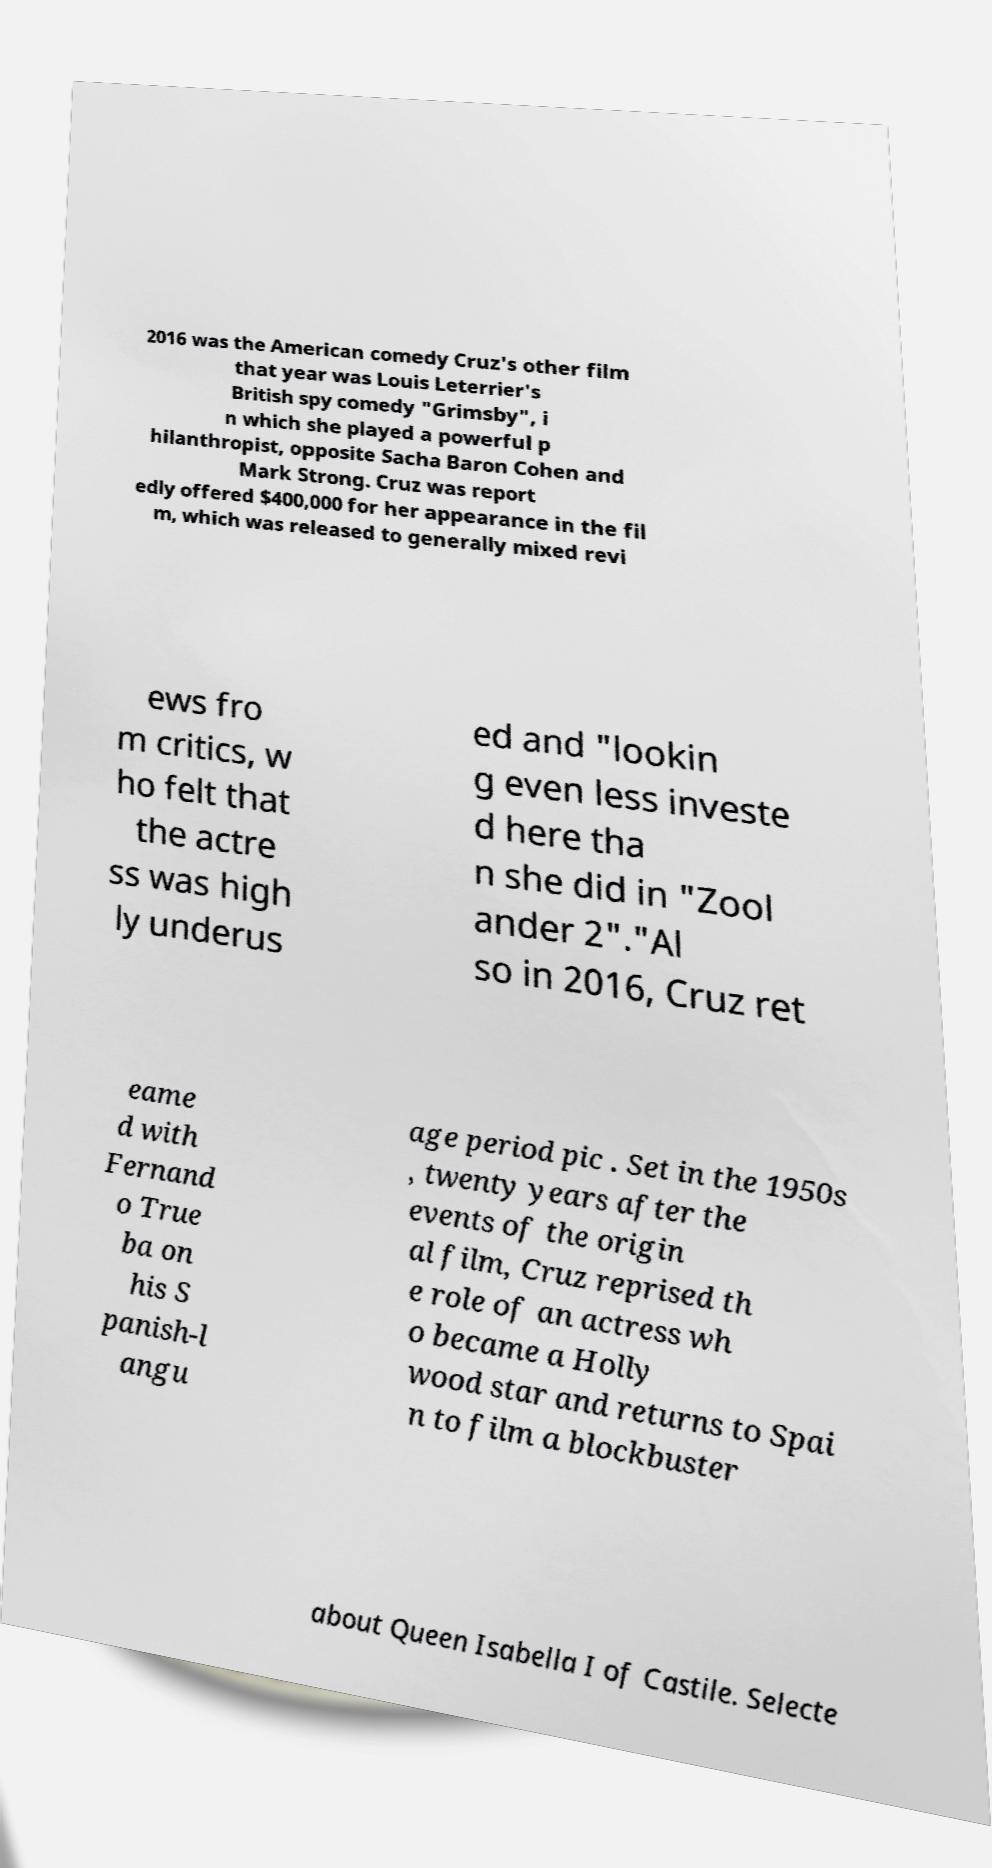Could you assist in decoding the text presented in this image and type it out clearly? 2016 was the American comedy Cruz's other film that year was Louis Leterrier's British spy comedy "Grimsby", i n which she played a powerful p hilanthropist, opposite Sacha Baron Cohen and Mark Strong. Cruz was report edly offered $400,000 for her appearance in the fil m, which was released to generally mixed revi ews fro m critics, w ho felt that the actre ss was high ly underus ed and "lookin g even less investe d here tha n she did in "Zool ander 2"."Al so in 2016, Cruz ret eame d with Fernand o True ba on his S panish-l angu age period pic . Set in the 1950s , twenty years after the events of the origin al film, Cruz reprised th e role of an actress wh o became a Holly wood star and returns to Spai n to film a blockbuster about Queen Isabella I of Castile. Selecte 